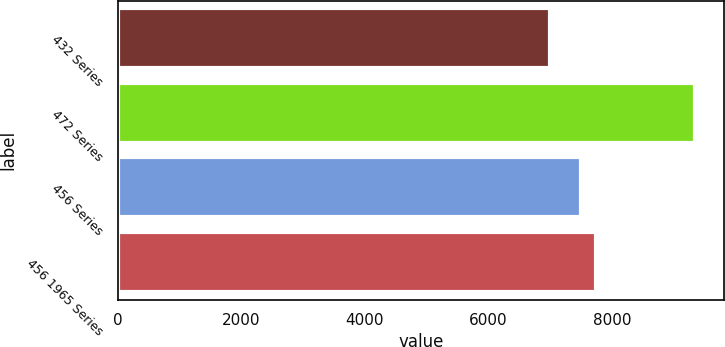<chart> <loc_0><loc_0><loc_500><loc_500><bar_chart><fcel>432 Series<fcel>472 Series<fcel>456 Series<fcel>456 1965 Series<nl><fcel>7000<fcel>9350<fcel>7500<fcel>7735<nl></chart> 